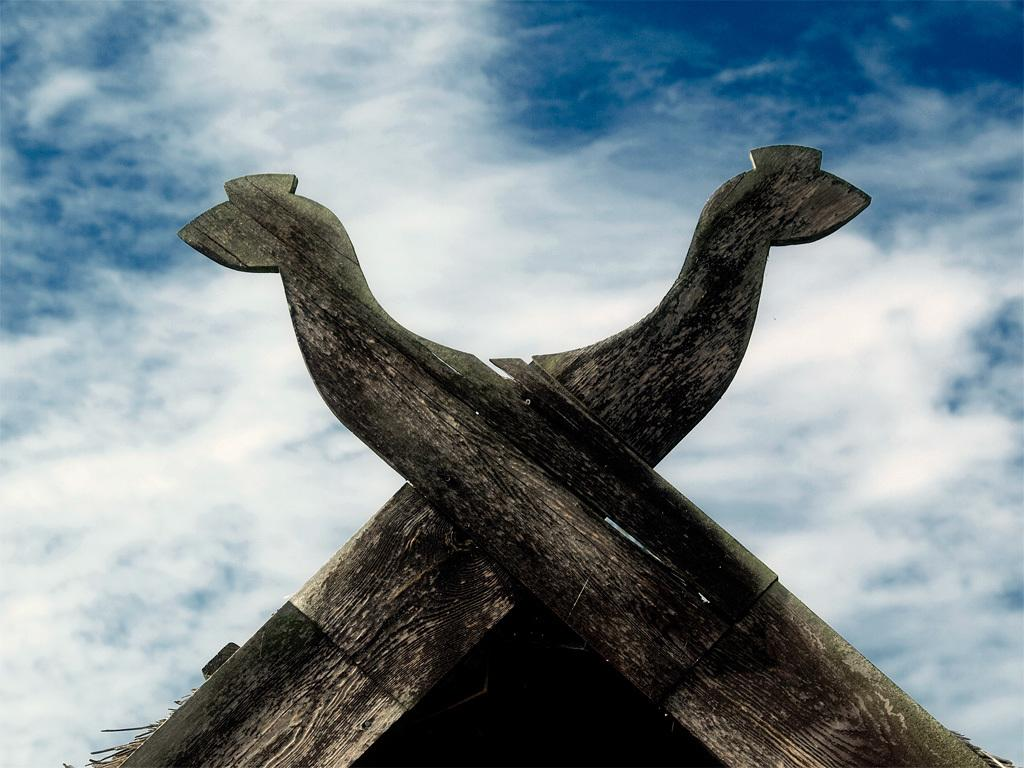What objects are made of wood in the image? There are two wooden planks in the image. What shape have the wooden planks been carved into? The wooden planks have been carved in the shape of an animal. What can be seen in the background of the image? The background of the image includes the sky. What type of weather can be inferred from the image? Clouds are visible in the sky, which suggests that it might be a partly cloudy day. Can you tell me how many snails are crawling on the wooden planks in the image? There are no snails present in the image; it features two wooden planks carved in the shape of an animal. What type of mitten is being used to carve the wooden planks in the image? There is no mitten visible in the image, and it does not show any carving process. 